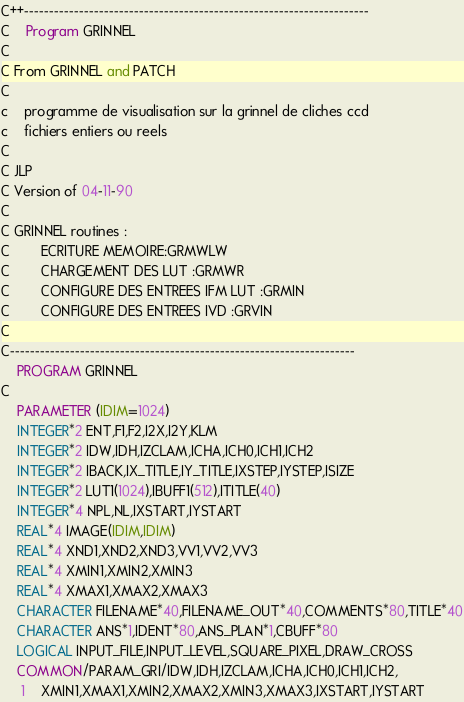<code> <loc_0><loc_0><loc_500><loc_500><_FORTRAN_>C++---------------------------------------------------------------------
C	Program GRINNEL
C
C From GRINNEL and PATCH
C
c	programme de visualisation sur la grinnel de cliches ccd
c	fichiers entiers ou reels
C
C JLP
C Version of 04-11-90
C
C GRINNEL routines :
C		ECRITURE MEMOIRE:GRMWLW
C		CHARGEMENT DES LUT :GRMWR
C		CONFIGURE DES ENTREES IFM LUT :GRMIN
C		CONFIGURE DES ENTREES IVD :GRVIN
C
C---------------------------------------------------------------------
	PROGRAM GRINNEL
C
	PARAMETER (IDIM=1024)
	INTEGER*2 ENT,F1,F2,I2X,I2Y,KLM
	INTEGER*2 IDW,IDH,IZCLAM,ICHA,ICH0,ICH1,ICH2
	INTEGER*2 IBACK,IX_TITLE,IY_TITLE,IXSTEP,IYSTEP,ISIZE
	INTEGER*2 LUT1(1024),IBUFF1(512),ITITLE(40)
	INTEGER*4 NPL,NL,IXSTART,IYSTART
	REAL*4 IMAGE(IDIM,IDIM)
	REAL*4 XND1,XND2,XND3,VV1,VV2,VV3
	REAL*4 XMIN1,XMIN2,XMIN3
	REAL*4 XMAX1,XMAX2,XMAX3
	CHARACTER FILENAME*40,FILENAME_OUT*40,COMMENTS*80,TITLE*40
	CHARACTER ANS*1,IDENT*80,ANS_PLAN*1,CBUFF*80
	LOGICAL INPUT_FILE,INPUT_LEVEL,SQUARE_PIXEL,DRAW_CROSS
	COMMON/PARAM_GRI/IDW,IDH,IZCLAM,ICHA,ICH0,ICH1,ICH2,
     1	XMIN1,XMAX1,XMIN2,XMAX2,XMIN3,XMAX3,IXSTART,IYSTART</code> 